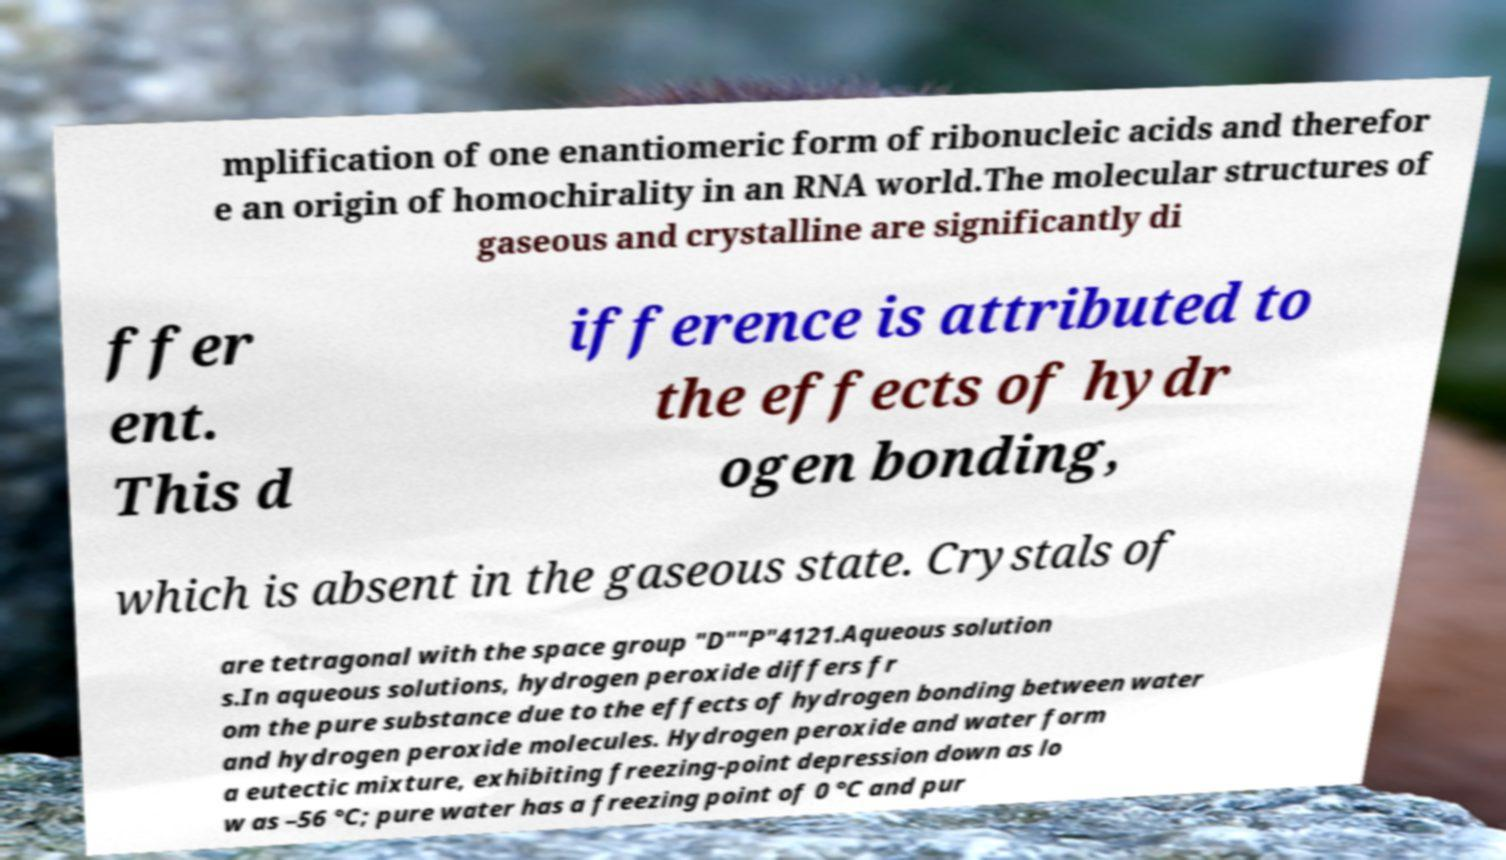Could you assist in decoding the text presented in this image and type it out clearly? mplification of one enantiomeric form of ribonucleic acids and therefor e an origin of homochirality in an RNA world.The molecular structures of gaseous and crystalline are significantly di ffer ent. This d ifference is attributed to the effects of hydr ogen bonding, which is absent in the gaseous state. Crystals of are tetragonal with the space group "D""P"4121.Aqueous solution s.In aqueous solutions, hydrogen peroxide differs fr om the pure substance due to the effects of hydrogen bonding between water and hydrogen peroxide molecules. Hydrogen peroxide and water form a eutectic mixture, exhibiting freezing-point depression down as lo w as –56 °C; pure water has a freezing point of 0 °C and pur 